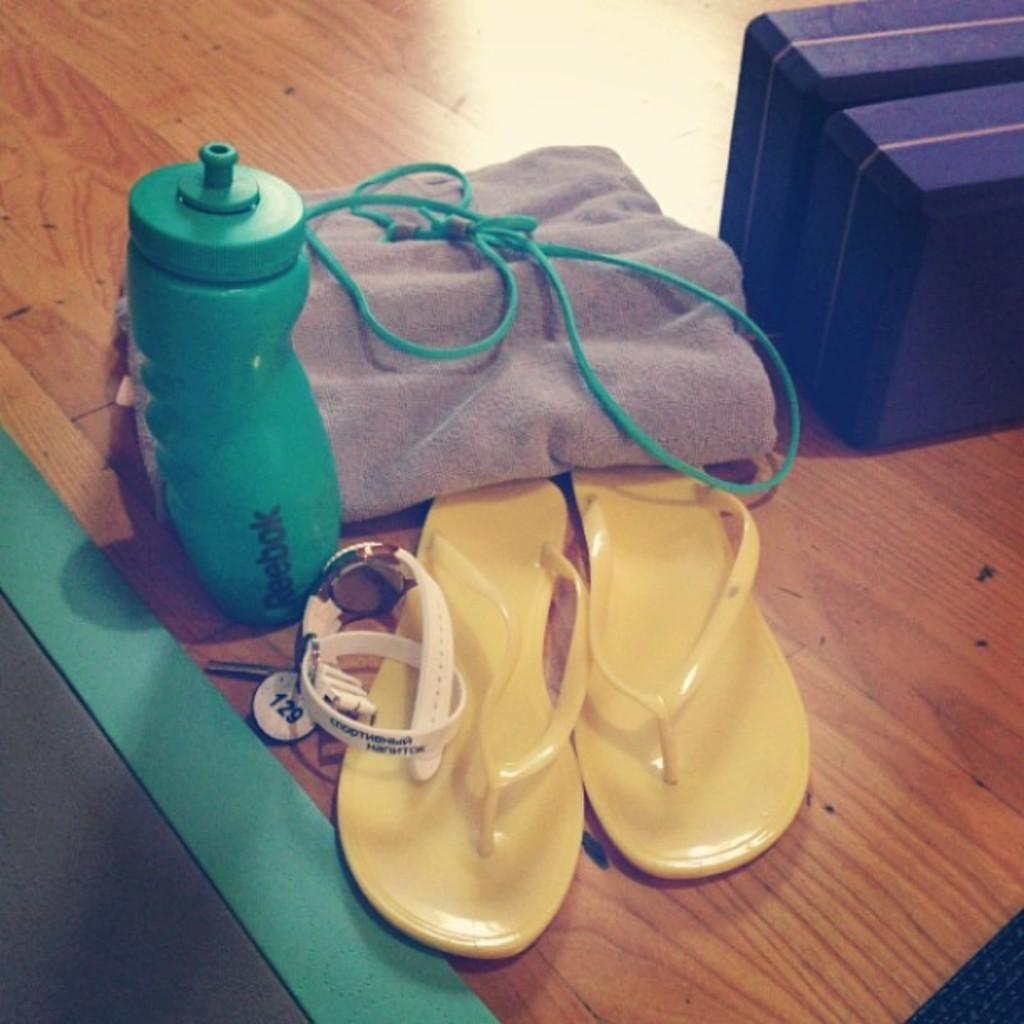What object is placed on the table in the image? There is a bottle on the table. What else can be seen on the table? There is a cloth, a rope, sandals, a watch, and keys on the table. What might be used for tying or securing in the image? The rope on the table might be used for tying or securing. What item on the table might be used for telling time? The watch on the table might be used for telling time. How does the sink help with the wish in the image? There is no sink present in the image, and therefore no wish can be granted or affected by it. 